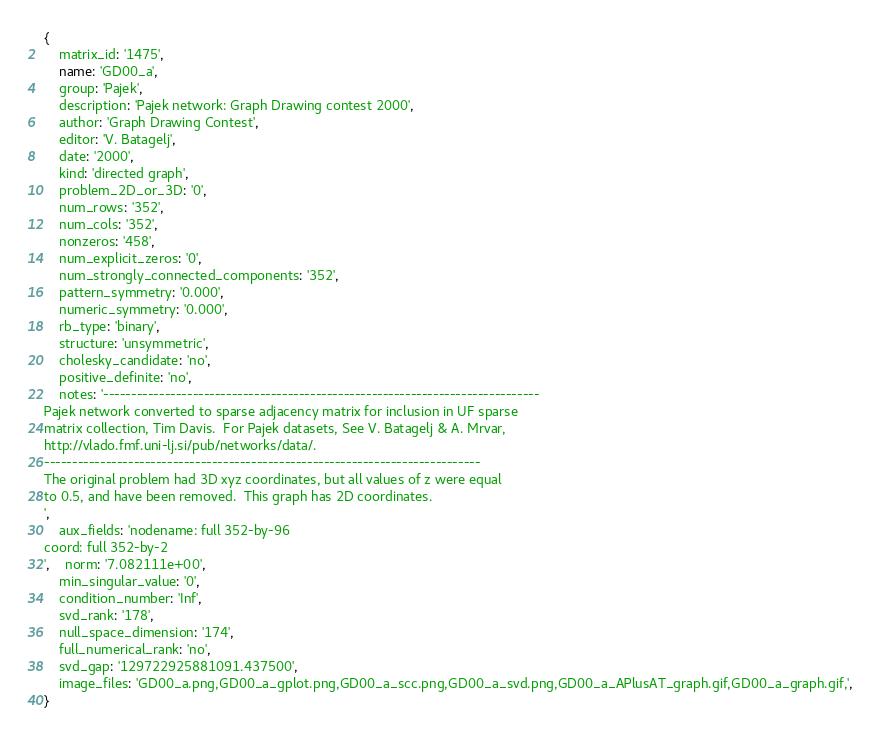Convert code to text. <code><loc_0><loc_0><loc_500><loc_500><_Ruby_>{
    matrix_id: '1475',
    name: 'GD00_a',
    group: 'Pajek',
    description: 'Pajek network: Graph Drawing contest 2000',
    author: 'Graph Drawing Contest',
    editor: 'V. Batagelj',
    date: '2000',
    kind: 'directed graph',
    problem_2D_or_3D: '0',
    num_rows: '352',
    num_cols: '352',
    nonzeros: '458',
    num_explicit_zeros: '0',
    num_strongly_connected_components: '352',
    pattern_symmetry: '0.000',
    numeric_symmetry: '0.000',
    rb_type: 'binary',
    structure: 'unsymmetric',
    cholesky_candidate: 'no',
    positive_definite: 'no',
    notes: '------------------------------------------------------------------------------
Pajek network converted to sparse adjacency matrix for inclusion in UF sparse 
matrix collection, Tim Davis.  For Pajek datasets, See V. Batagelj & A. Mrvar,
http://vlado.fmf.uni-lj.si/pub/networks/data/.                                
------------------------------------------------------------------------------
The original problem had 3D xyz coordinates, but all values of z were equal   
to 0.5, and have been removed.  This graph has 2D coordinates.                
',
    aux_fields: 'nodename: full 352-by-96
coord: full 352-by-2
',    norm: '7.082111e+00',
    min_singular_value: '0',
    condition_number: 'Inf',
    svd_rank: '178',
    null_space_dimension: '174',
    full_numerical_rank: 'no',
    svd_gap: '129722925881091.437500',
    image_files: 'GD00_a.png,GD00_a_gplot.png,GD00_a_scc.png,GD00_a_svd.png,GD00_a_APlusAT_graph.gif,GD00_a_graph.gif,',
}
</code> 